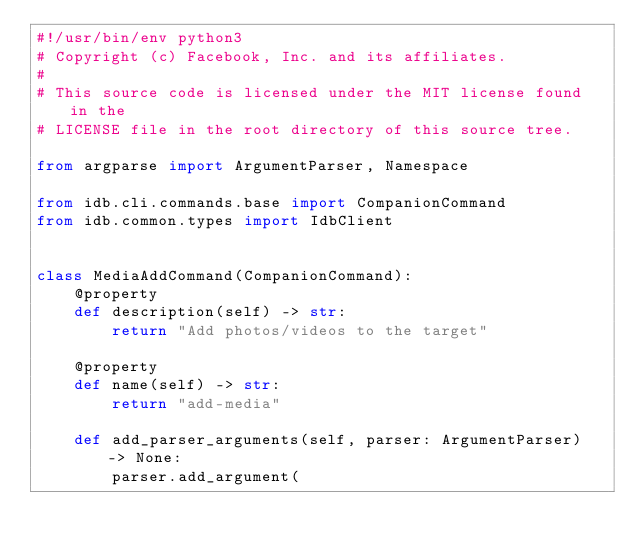<code> <loc_0><loc_0><loc_500><loc_500><_Python_>#!/usr/bin/env python3
# Copyright (c) Facebook, Inc. and its affiliates.
#
# This source code is licensed under the MIT license found in the
# LICENSE file in the root directory of this source tree.

from argparse import ArgumentParser, Namespace

from idb.cli.commands.base import CompanionCommand
from idb.common.types import IdbClient


class MediaAddCommand(CompanionCommand):
    @property
    def description(self) -> str:
        return "Add photos/videos to the target"

    @property
    def name(self) -> str:
        return "add-media"

    def add_parser_arguments(self, parser: ArgumentParser) -> None:
        parser.add_argument(</code> 